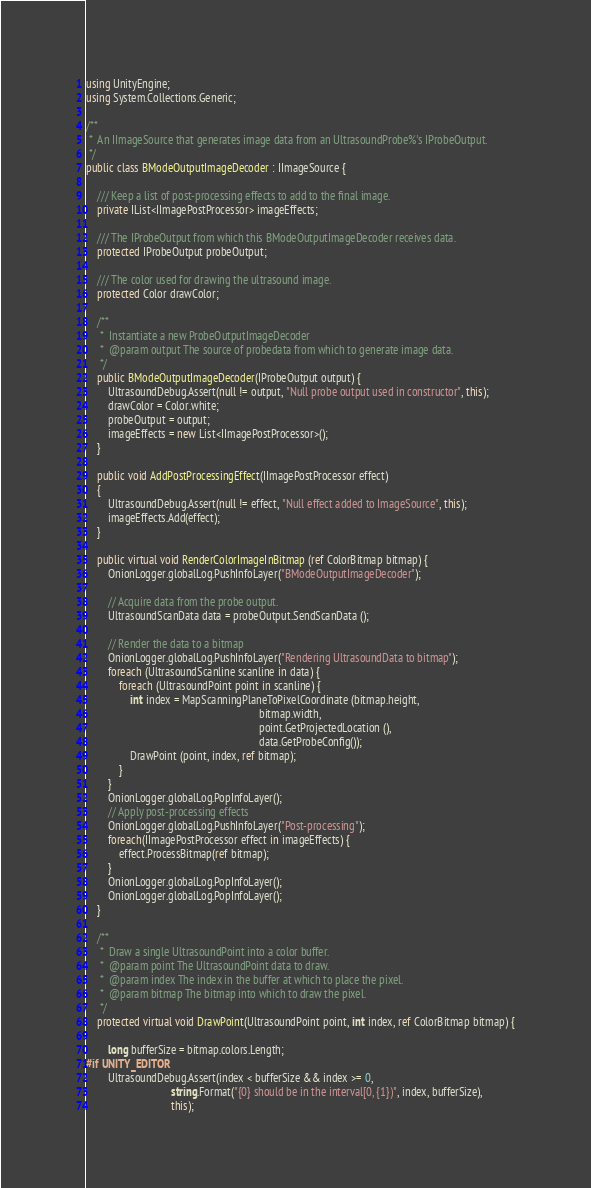<code> <loc_0><loc_0><loc_500><loc_500><_C#_>using UnityEngine;
using System.Collections.Generic;

/**
 *  An IImageSource that generates image data from an UltrasoundProbe%'s IProbeOutput.
 */
public class BModeOutputImageDecoder : IImageSource {

	/// Keep a list of post-processing effects to add to the final image.
	private IList<IImagePostProcessor> imageEffects;

	///	The IProbeOutput from which this BModeOutputImageDecoder receives data.
    protected IProbeOutput probeOutput;

	/// The color used for drawing the ultrasound image.
    protected Color drawColor;

    /**
     *  Instantiate a new ProbeOutputImageDecoder
     *  @param output The source of probedata from which to generate image data.
     */
    public BModeOutputImageDecoder(IProbeOutput output) {
		UltrasoundDebug.Assert(null != output, "Null probe output used in constructor", this);
		drawColor = Color.white;
        probeOutput = output;
		imageEffects = new List<IImagePostProcessor>();
    }

	public void AddPostProcessingEffect(IImagePostProcessor effect)
	{
		UltrasoundDebug.Assert(null != effect, "Null effect added to ImageSource", this);
		imageEffects.Add(effect);
	}

	public virtual void RenderColorImageInBitmap (ref ColorBitmap bitmap) {
		OnionLogger.globalLog.PushInfoLayer("BModeOutputImageDecoder");

		// Acquire data from the probe output.
        UltrasoundScanData data = probeOutput.SendScanData ();

		// Render the data to a bitmap
		OnionLogger.globalLog.PushInfoLayer("Rendering UltrasoundData to bitmap");
        foreach (UltrasoundScanline scanline in data) {
            foreach (UltrasoundPoint point in scanline) {
                int index = MapScanningPlaneToPixelCoordinate (bitmap.height, 
                                                               bitmap.width, 
                                                               point.GetProjectedLocation (),
				                                               data.GetProbeConfig());
                DrawPoint (point, index, ref bitmap);
            }
        }
		OnionLogger.globalLog.PopInfoLayer();
		// Apply post-processing effects
		OnionLogger.globalLog.PushInfoLayer("Post-processing");
		foreach(IImagePostProcessor effect in imageEffects) {
			effect.ProcessBitmap(ref bitmap);
		}
		OnionLogger.globalLog.PopInfoLayer();
		OnionLogger.globalLog.PopInfoLayer();
    }

    /**
     *  Draw a single UltrasoundPoint into a color buffer.
     *  @param point The UltrasoundPoint data to draw.
     *  @param index The index in the buffer at which to place the pixel.
     *  @param bitmap The bitmap into which to draw the pixel.
     */
    protected virtual void DrawPoint(UltrasoundPoint point, int index, ref ColorBitmap bitmap) {

		long bufferSize = bitmap.colors.Length;
#if UNITY_EDITOR
		UltrasoundDebug.Assert(index < bufferSize && index >= 0,
		                       string.Format("{0} should be in the interval[0, {1})", index, bufferSize),
		                       this);</code> 